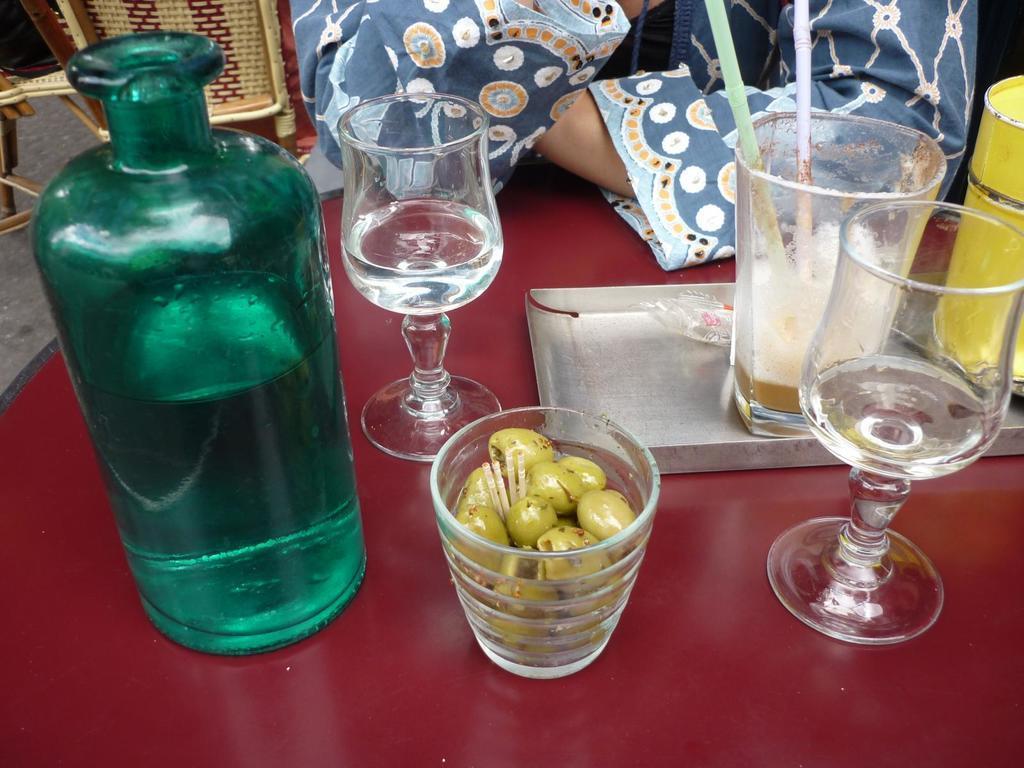Describe this image in one or two sentences. In the image we can see there is a bottle and a wine glass and in a tray there is a juice glass. 